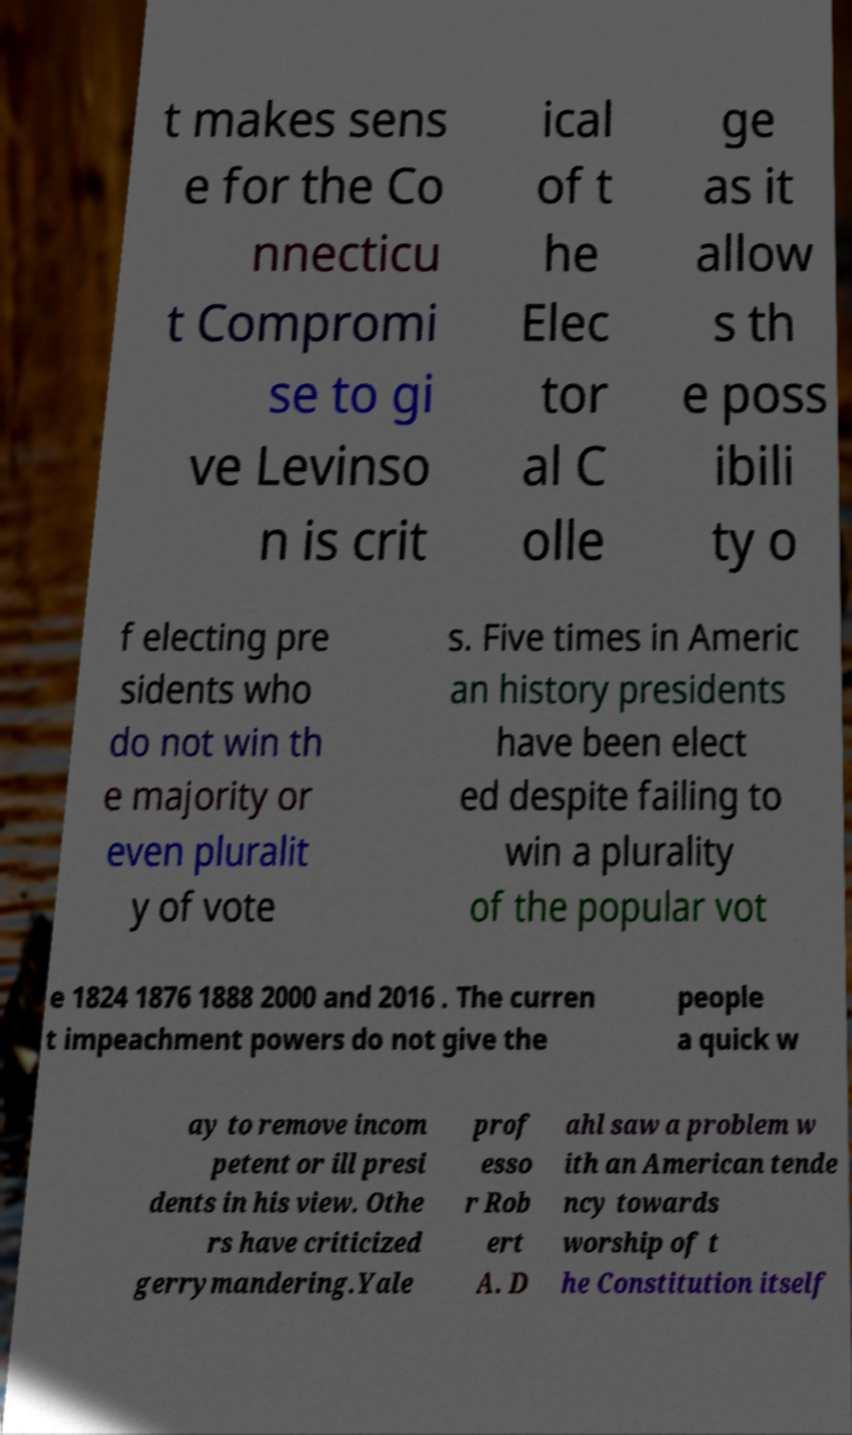For documentation purposes, I need the text within this image transcribed. Could you provide that? t makes sens e for the Co nnecticu t Compromi se to gi ve Levinso n is crit ical of t he Elec tor al C olle ge as it allow s th e poss ibili ty o f electing pre sidents who do not win th e majority or even pluralit y of vote s. Five times in Americ an history presidents have been elect ed despite failing to win a plurality of the popular vot e 1824 1876 1888 2000 and 2016 . The curren t impeachment powers do not give the people a quick w ay to remove incom petent or ill presi dents in his view. Othe rs have criticized gerrymandering.Yale prof esso r Rob ert A. D ahl saw a problem w ith an American tende ncy towards worship of t he Constitution itself 